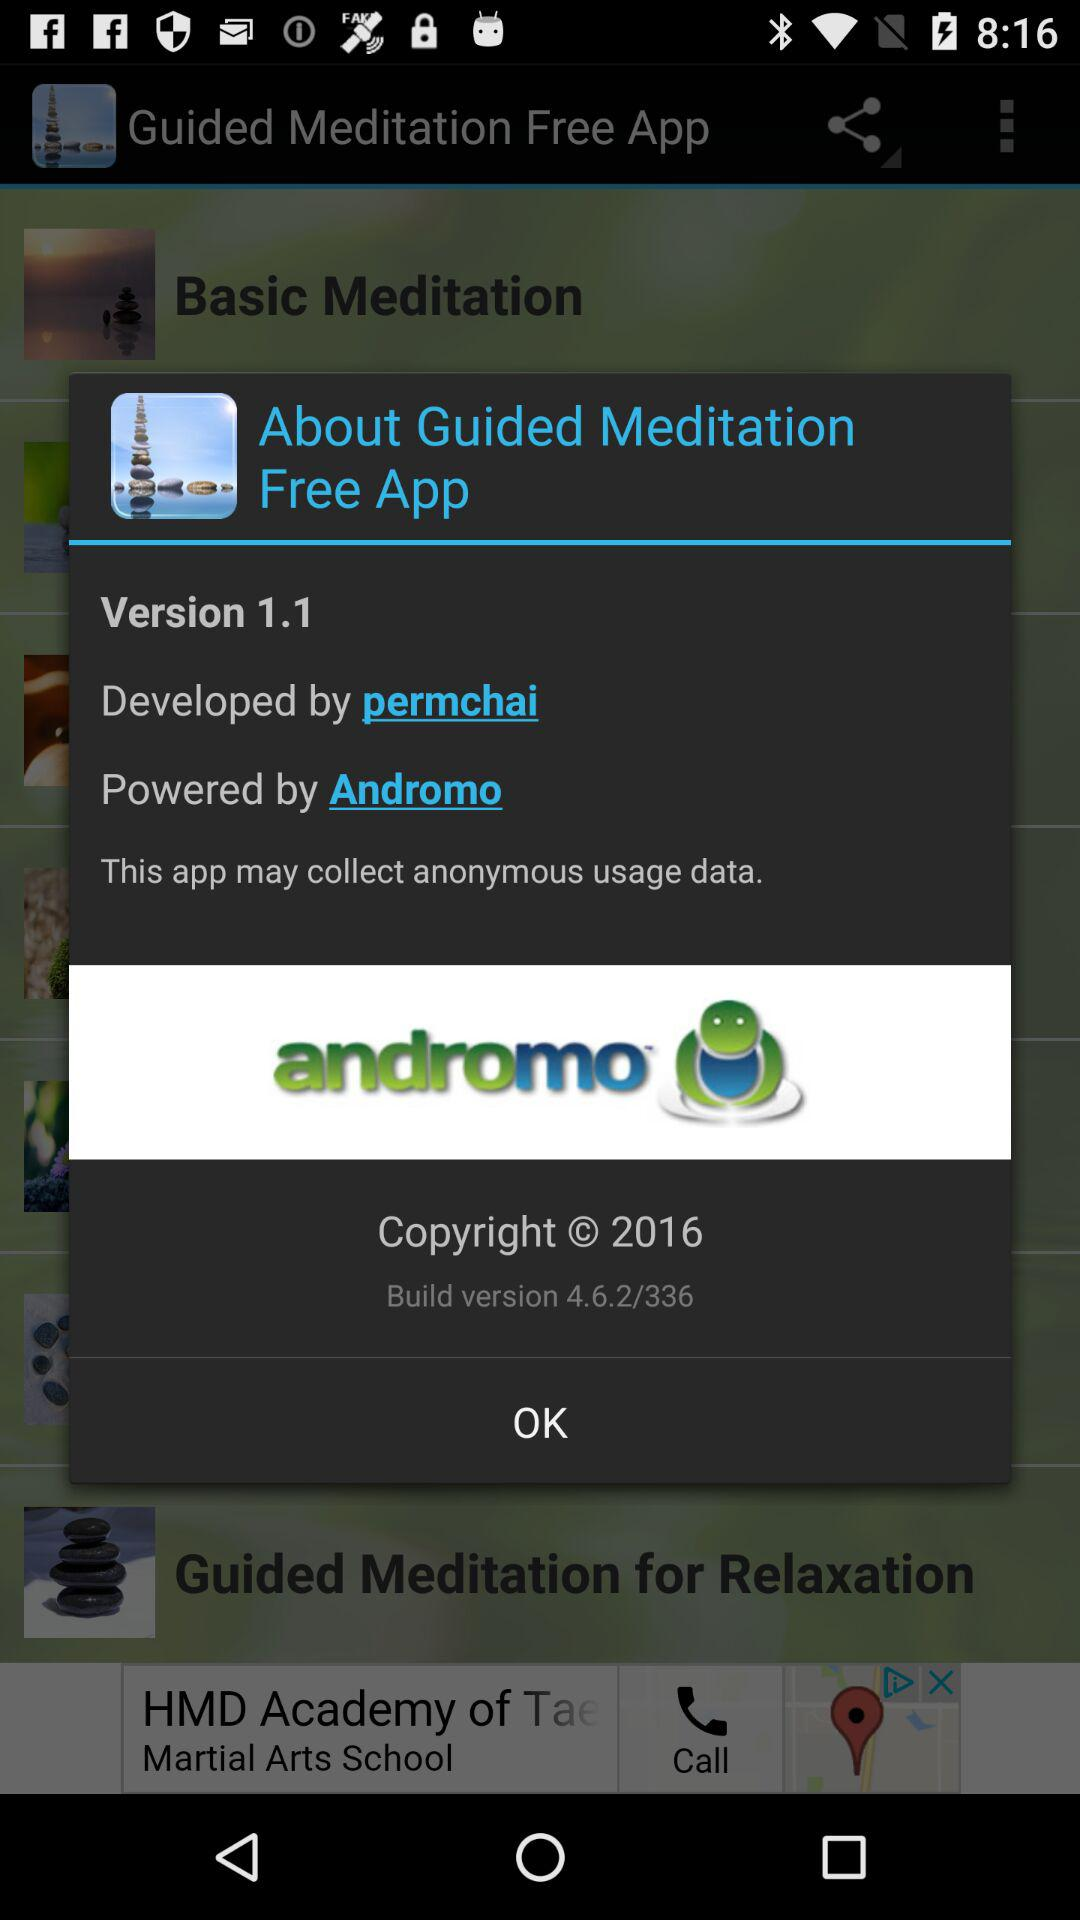Who is the developer? The developer is Permchai. 